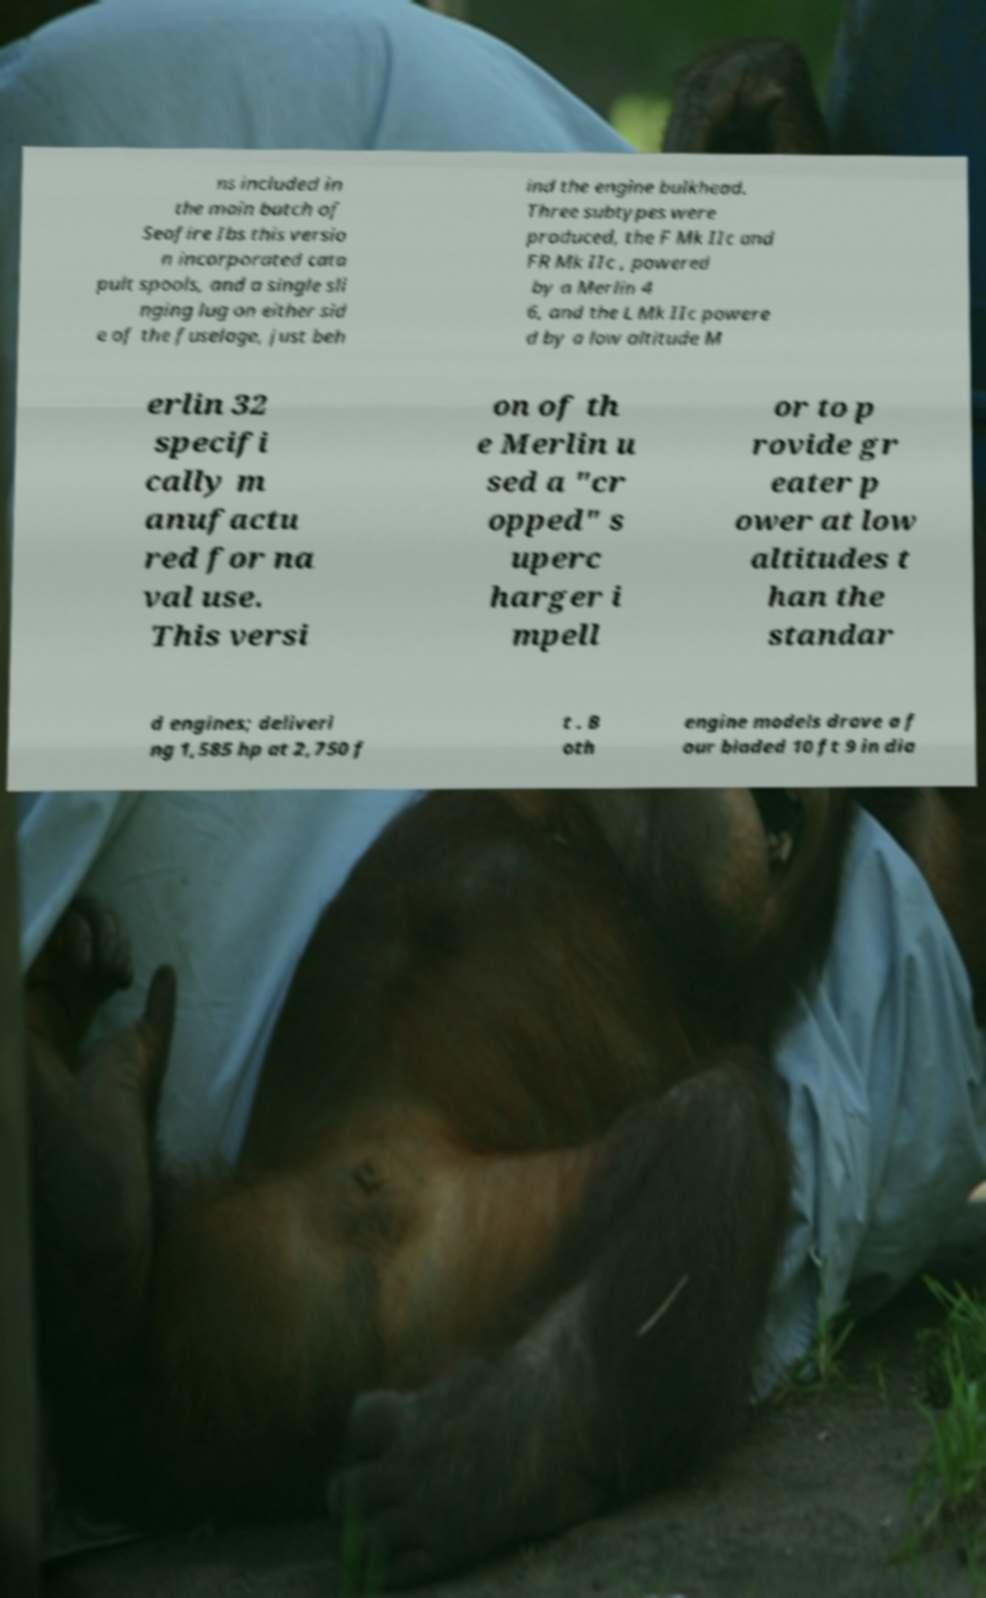I need the written content from this picture converted into text. Can you do that? ns included in the main batch of Seafire Ibs this versio n incorporated cata pult spools, and a single sli nging lug on either sid e of the fuselage, just beh ind the engine bulkhead. Three subtypes were produced, the F Mk IIc and FR Mk IIc , powered by a Merlin 4 6, and the L Mk IIc powere d by a low altitude M erlin 32 specifi cally m anufactu red for na val use. This versi on of th e Merlin u sed a "cr opped" s uperc harger i mpell or to p rovide gr eater p ower at low altitudes t han the standar d engines; deliveri ng 1,585 hp at 2,750 f t . B oth engine models drove a f our bladed 10 ft 9 in dia 